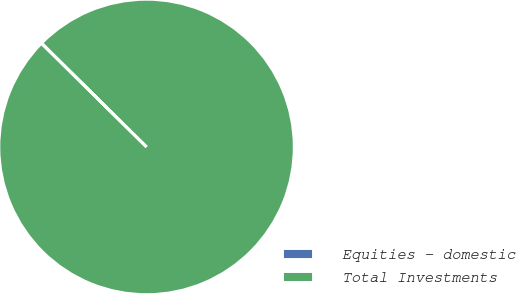<chart> <loc_0><loc_0><loc_500><loc_500><pie_chart><fcel>Equities - domestic<fcel>Total Investments<nl><fcel>0.04%<fcel>99.96%<nl></chart> 